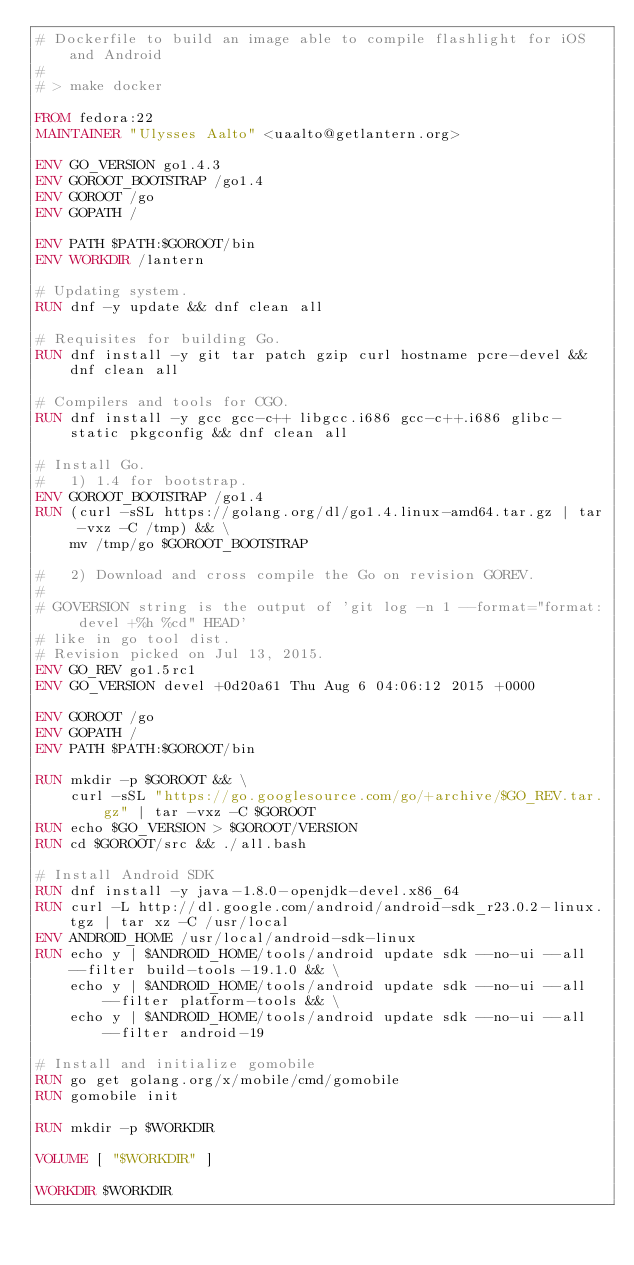Convert code to text. <code><loc_0><loc_0><loc_500><loc_500><_Dockerfile_># Dockerfile to build an image able to compile flashlight for iOS and Android
#
# > make docker

FROM fedora:22
MAINTAINER "Ulysses Aalto" <uaalto@getlantern.org>

ENV GO_VERSION go1.4.3
ENV GOROOT_BOOTSTRAP /go1.4
ENV GOROOT /go
ENV GOPATH /

ENV PATH $PATH:$GOROOT/bin
ENV WORKDIR /lantern

# Updating system.
RUN dnf -y update && dnf clean all

# Requisites for building Go.
RUN dnf install -y git tar patch gzip curl hostname pcre-devel && dnf clean all

# Compilers and tools for CGO.
RUN dnf install -y gcc gcc-c++ libgcc.i686 gcc-c++.i686 glibc-static pkgconfig && dnf clean all

# Install Go.
#   1) 1.4 for bootstrap.
ENV GOROOT_BOOTSTRAP /go1.4
RUN (curl -sSL https://golang.org/dl/go1.4.linux-amd64.tar.gz | tar -vxz -C /tmp) && \
	mv /tmp/go $GOROOT_BOOTSTRAP

#   2) Download and cross compile the Go on revision GOREV.
#
# GOVERSION string is the output of 'git log -n 1 --format="format: devel +%h %cd" HEAD'
# like in go tool dist.
# Revision picked on Jul 13, 2015.
ENV GO_REV go1.5rc1
ENV GO_VERSION devel +0d20a61 Thu Aug 6 04:06:12 2015 +0000

ENV GOROOT /go
ENV GOPATH /
ENV PATH $PATH:$GOROOT/bin

RUN mkdir -p $GOROOT && \
    curl -sSL "https://go.googlesource.com/go/+archive/$GO_REV.tar.gz" | tar -vxz -C $GOROOT
RUN echo $GO_VERSION > $GOROOT/VERSION
RUN cd $GOROOT/src && ./all.bash

# Install Android SDK
RUN dnf install -y java-1.8.0-openjdk-devel.x86_64
RUN curl -L http://dl.google.com/android/android-sdk_r23.0.2-linux.tgz | tar xz -C /usr/local
ENV ANDROID_HOME /usr/local/android-sdk-linux
RUN echo y | $ANDROID_HOME/tools/android update sdk --no-ui --all --filter build-tools-19.1.0 && \
	echo y | $ANDROID_HOME/tools/android update sdk --no-ui --all --filter platform-tools && \
	echo y | $ANDROID_HOME/tools/android update sdk --no-ui --all --filter android-19

# Install and initialize gomobile
RUN go get golang.org/x/mobile/cmd/gomobile
RUN gomobile init

RUN mkdir -p $WORKDIR

VOLUME [ "$WORKDIR" ]

WORKDIR $WORKDIR
</code> 